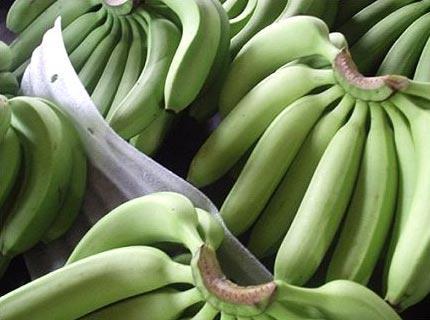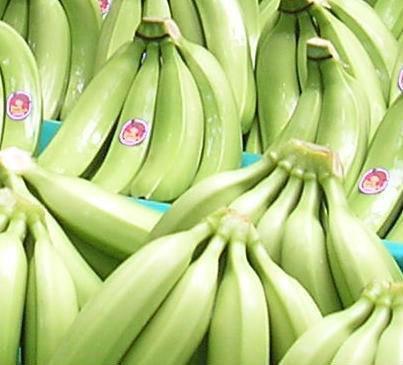The first image is the image on the left, the second image is the image on the right. Examine the images to the left and right. Is the description "There is an image with one bunch of unripe bananas, and another image with multiple bunches." accurate? Answer yes or no. No. The first image is the image on the left, the second image is the image on the right. For the images displayed, is the sentence "One image includes only one small bunch of green bananas, with no more than five bananas visible." factually correct? Answer yes or no. No. 